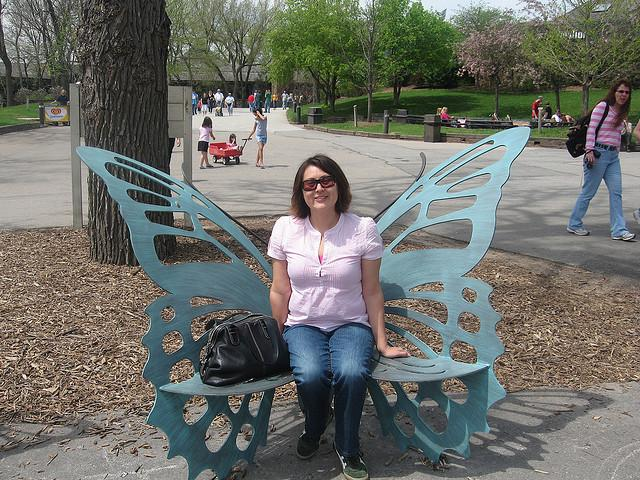What is the process that produces the type of animal depicted on the bench called?

Choices:
A) germination
B) pollination
C) metamorphosis
D) mitosis metamorphosis 